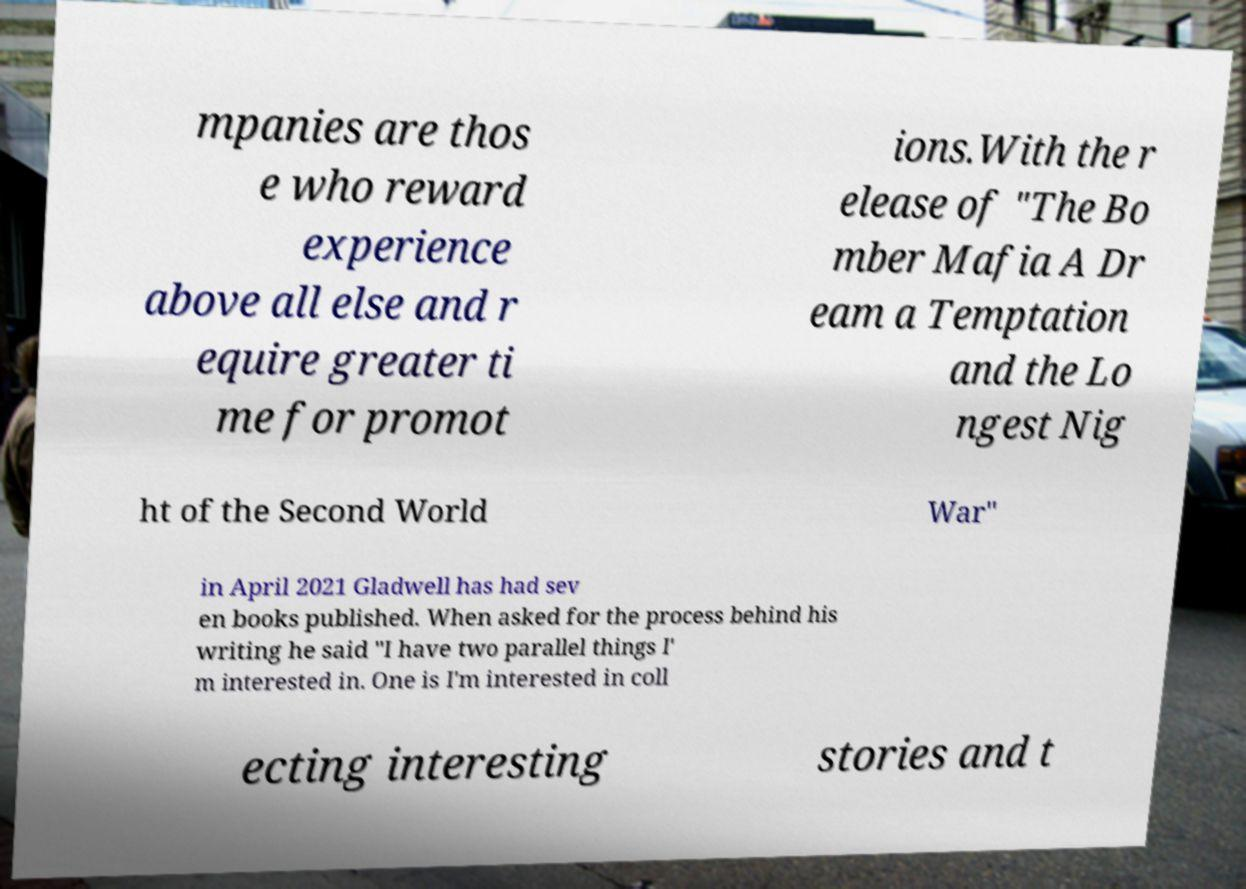Could you assist in decoding the text presented in this image and type it out clearly? mpanies are thos e who reward experience above all else and r equire greater ti me for promot ions.With the r elease of "The Bo mber Mafia A Dr eam a Temptation and the Lo ngest Nig ht of the Second World War" in April 2021 Gladwell has had sev en books published. When asked for the process behind his writing he said "I have two parallel things I' m interested in. One is I'm interested in coll ecting interesting stories and t 